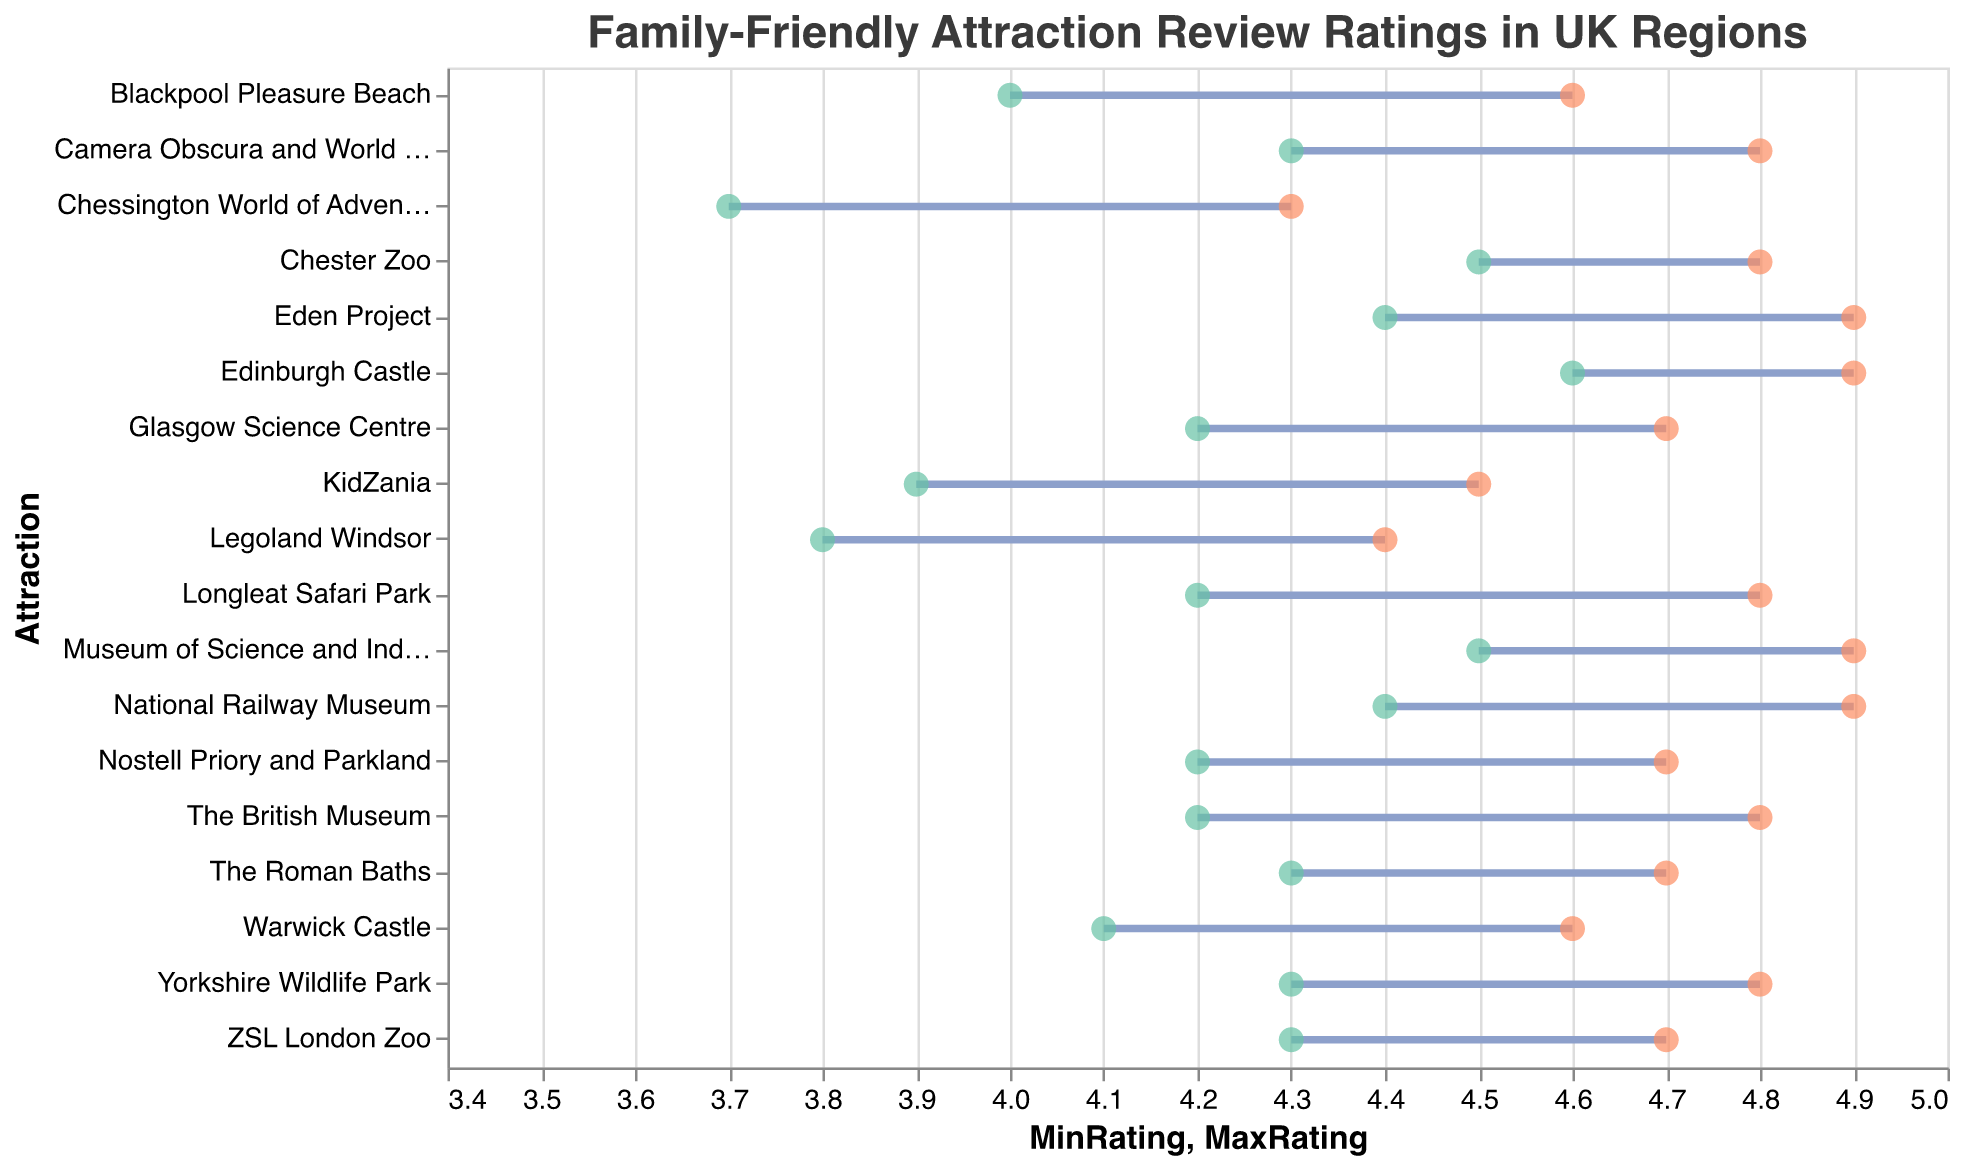Which region has the highest-rated attraction? Edinburgh Castle in Scotland has the highest maximum rating of 4.9 as indicated by the topmost part of the dot plot, marked with the red dot at 4.9.
Answer: Scotland What is the range of ratings for the Eden Project? The Eden Project has a minimum rating of 4.4 and a maximum rating of 4.9, as shown by the width of the rule line, which starts at 4.4 (green dot) and ends at 4.9 (red dot).
Answer: Range: 4.4 to 4.9 Which attraction in London has the largest difference between its minimum and maximum ratings? By comparing the lengths of the rule lines for London attractions, KidZania has the largest difference between its minimum rating (3.9) and maximum rating (4.5), yielding a difference of 0.6.
Answer: KidZania How many attractions have a maximum rating of 4.9? From the plot, you can count the red dots that reach 4.9. There are five such attractions: Eden Project, Museum of Science and Industry, National Railway Museum, Edinburgh Castle, and Camera Obscura and World of Illusions.
Answer: 5 Which region has the most consistently high-rated attractions? By observing the plots, Scotland and North West have consistently high maximum ratings close to 4.9 or 4.8 for all their listed attractions, while other regions have more varied ratings.
Answer: Scotland and North West What is the average minimum rating for South East attractions? Sum the minimum ratings of South East attractions: Warwick Castle (4.1), Legoland Windsor (3.8), and Chessington World of Adventures (3.7). The total is 4.1 + 3.8 + 3.7 = 11.6. Divide this by 3 attractions to get the average: 11.6 / 3 = 3.87.
Answer: 3.87 Which attraction has the smallest rating range, and what is the range? To find this, look for the shortest rule line. Edinburgh Castle in Scotland has the smallest range, with both its minimum and maximum ratings at 4.9, resulting in a range of 0.
Answer: Edinburgh Castle, Range: 0 Compare the rating range for Chester Zoo and ZSL London Zoo. Which one has a larger range? Chester Zoo has a minimum rating of 4.5 and a maximum rating of 4.8 (range of 0.3). ZSL London Zoo has a minimum rating of 4.3 and a maximum rating of 4.7 (range of 0.4). Therefore, ZSL London Zoo has a larger range.
Answer: ZSL London Zoo What is the combined range of all attractions in North West? Combine the ranges of North West attractions: Blackpool Pleasure Beach (4.0 to 4.6), Museum of Science and Industry (4.5 to 4.9), and Chester Zoo (4.5 to 4.8). Calculate each range: 0.6, 0.4, and 0.3. Sum these to get the combined range: 0.6 + 0.4 + 0.3 = 1.3.
Answer: 1.3 